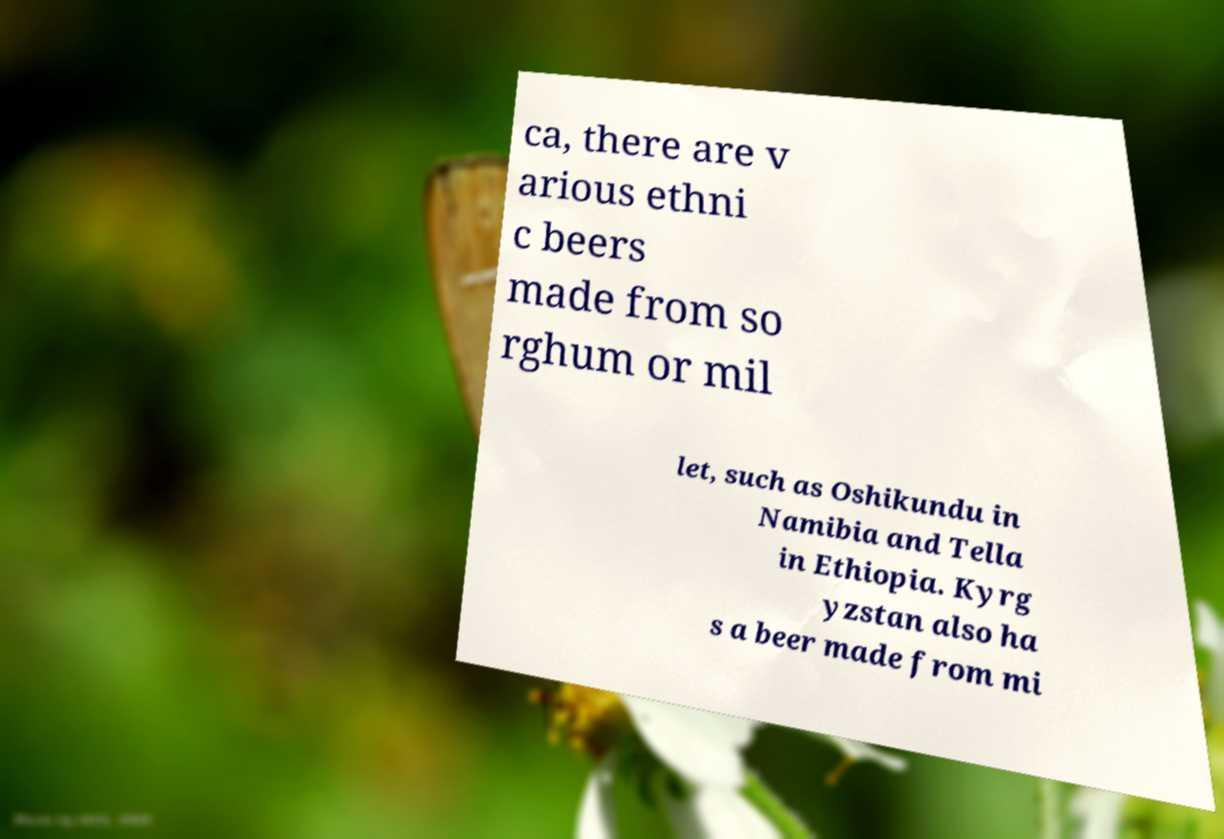What messages or text are displayed in this image? I need them in a readable, typed format. ca, there are v arious ethni c beers made from so rghum or mil let, such as Oshikundu in Namibia and Tella in Ethiopia. Kyrg yzstan also ha s a beer made from mi 